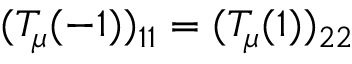Convert formula to latex. <formula><loc_0><loc_0><loc_500><loc_500>( T _ { \mu } ( - 1 ) ) _ { 1 1 } = ( T _ { \mu } ( 1 ) ) _ { 2 2 }</formula> 